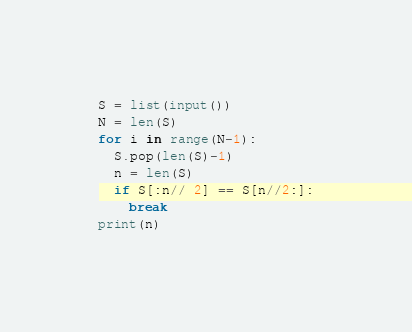Convert code to text. <code><loc_0><loc_0><loc_500><loc_500><_Python_>S = list(input())
N = len(S)
for i in range(N-1):
  S.pop(len(S)-1)
  n = len(S)
  if S[:n// 2] == S[n//2:]:
    break
print(n)</code> 